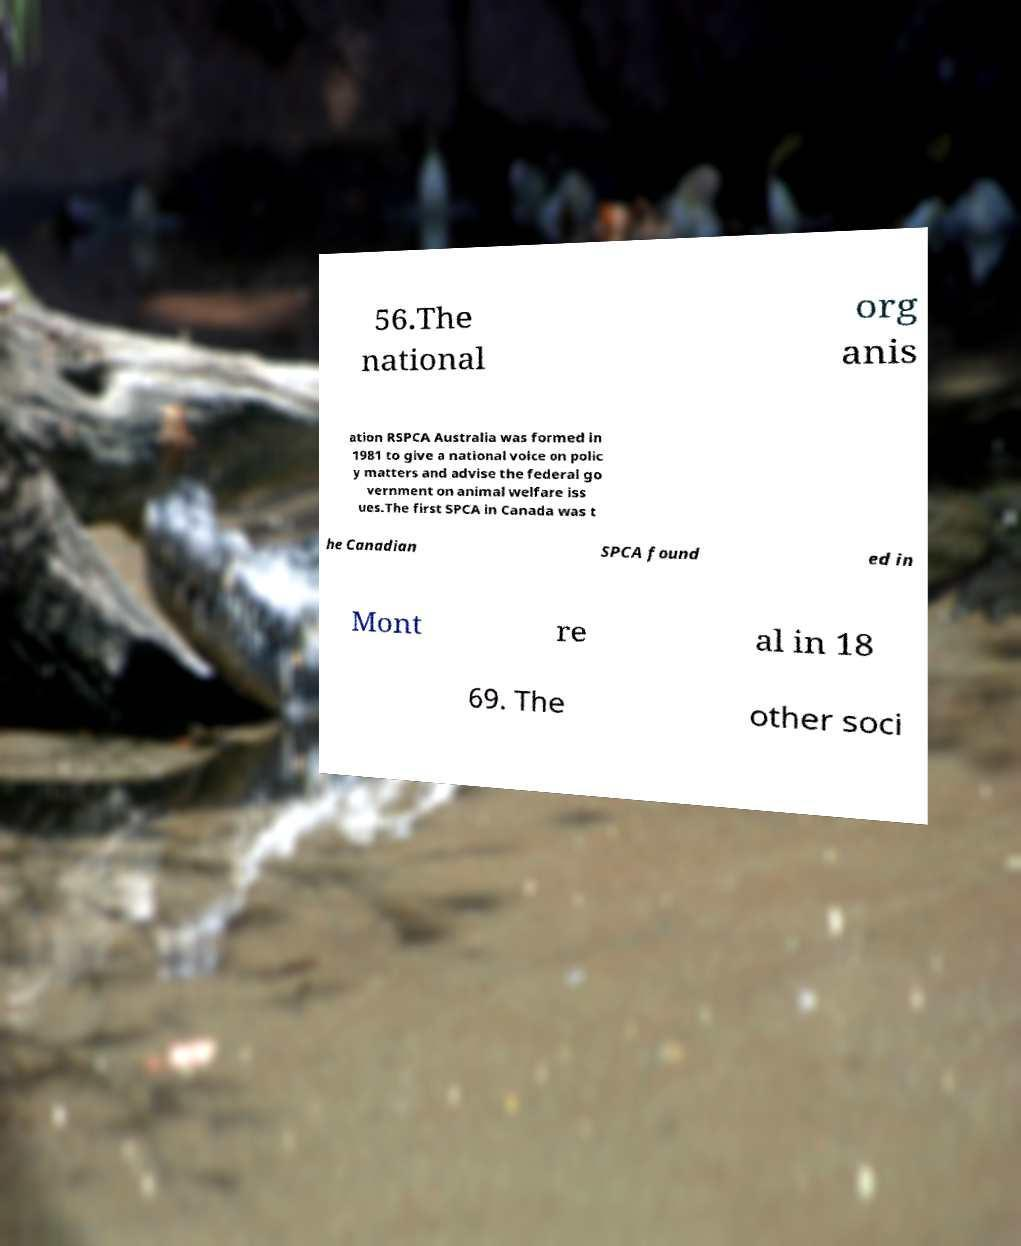There's text embedded in this image that I need extracted. Can you transcribe it verbatim? 56.The national org anis ation RSPCA Australia was formed in 1981 to give a national voice on polic y matters and advise the federal go vernment on animal welfare iss ues.The first SPCA in Canada was t he Canadian SPCA found ed in Mont re al in 18 69. The other soci 